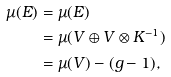<formula> <loc_0><loc_0><loc_500><loc_500>\mu ( E ) & = \mu ( E ) \\ & = \mu ( V \oplus V \otimes K ^ { - 1 } ) \\ & = \mu ( V ) - ( g - 1 ) ,</formula> 